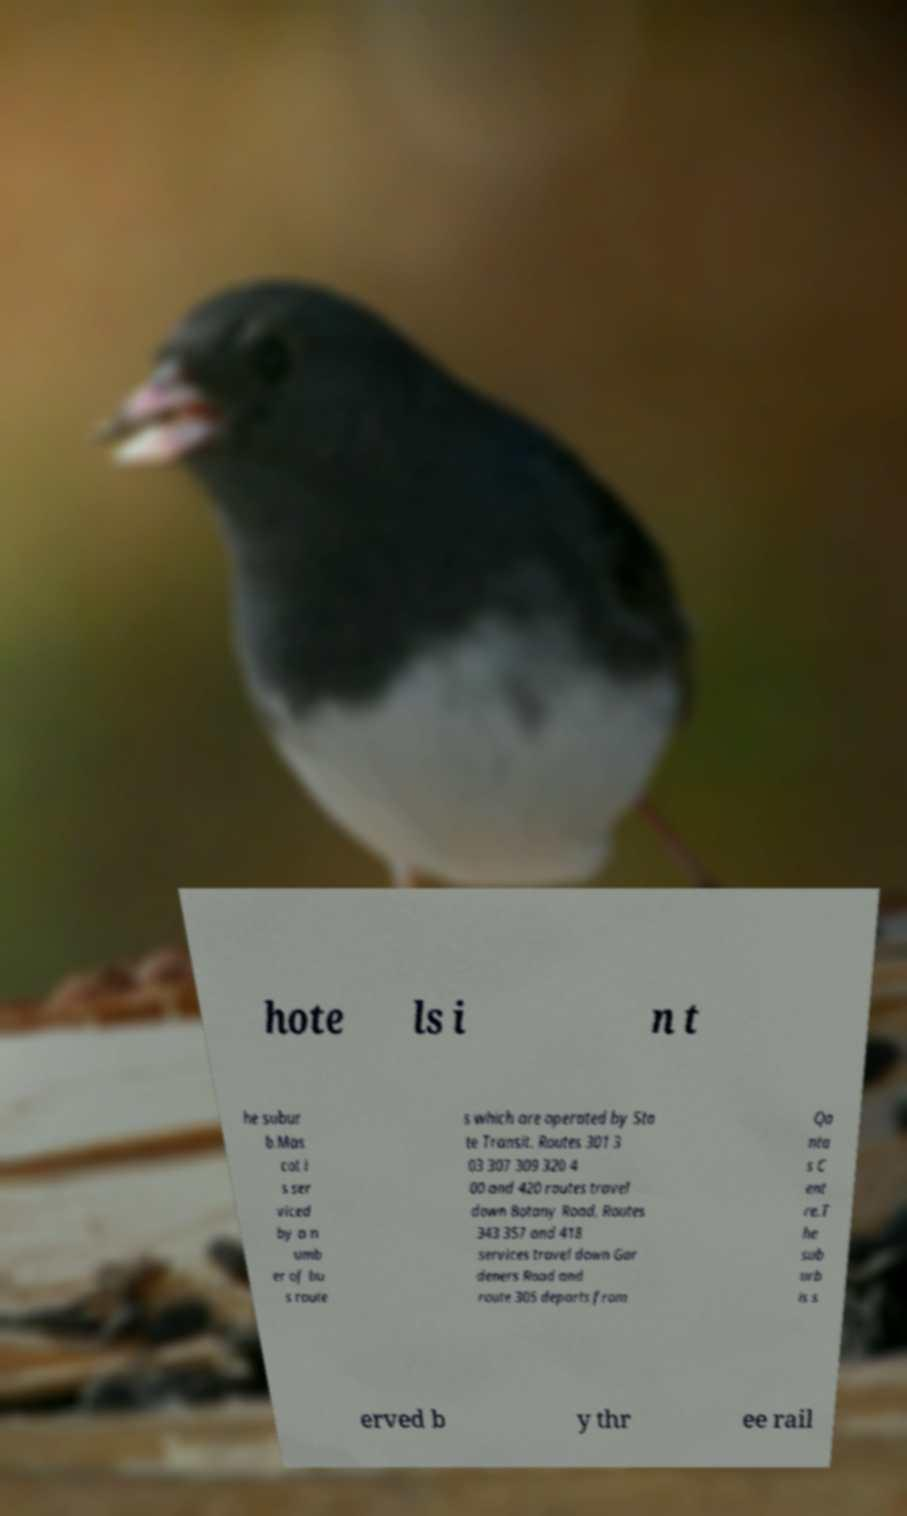I need the written content from this picture converted into text. Can you do that? hote ls i n t he subur b.Mas cot i s ser viced by a n umb er of bu s route s which are operated by Sta te Transit. Routes 301 3 03 307 309 320 4 00 and 420 routes travel down Botany Road. Routes 343 357 and 418 services travel down Gar deners Road and route 305 departs from Qa nta s C ent re.T he sub urb is s erved b y thr ee rail 